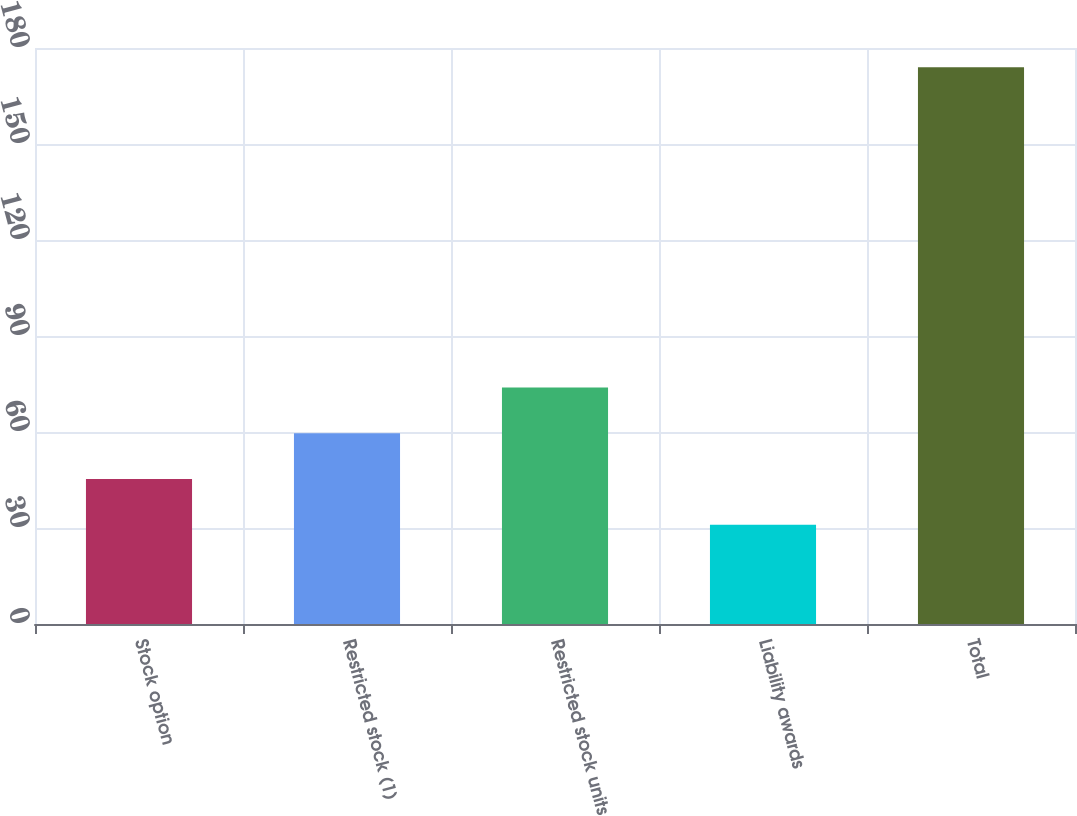Convert chart. <chart><loc_0><loc_0><loc_500><loc_500><bar_chart><fcel>Stock option<fcel>Restricted stock (1)<fcel>Restricted stock units<fcel>Liability awards<fcel>Total<nl><fcel>45.3<fcel>59.6<fcel>73.9<fcel>31<fcel>174<nl></chart> 